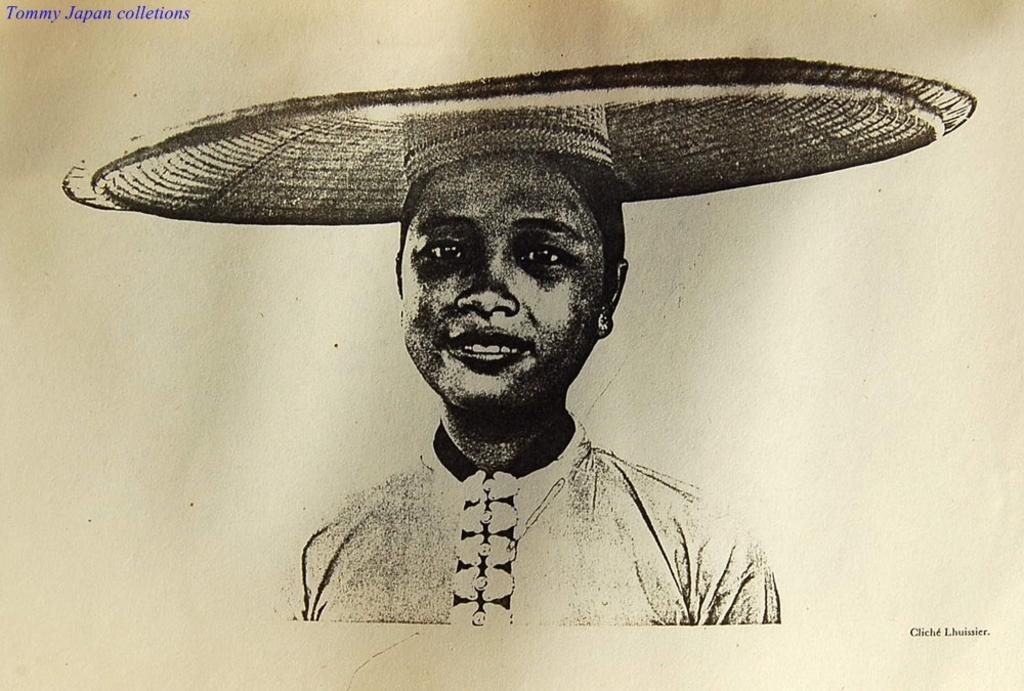In one or two sentences, can you explain what this image depicts? In this image there is a painting of a women, in the top left there is text, in the bottom right there is text. 